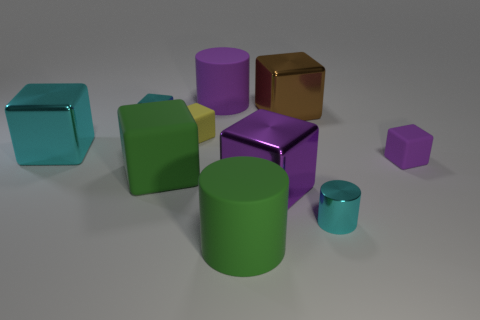Subtract all metal cylinders. How many cylinders are left? 2 Subtract all brown blocks. How many blocks are left? 6 Subtract all cylinders. How many objects are left? 7 Subtract all cyan cylinders. Subtract all green blocks. How many cylinders are left? 2 Subtract all gray spheres. How many cyan cylinders are left? 1 Subtract all small yellow rubber cylinders. Subtract all brown things. How many objects are left? 9 Add 2 small matte blocks. How many small matte blocks are left? 4 Add 5 big purple rubber objects. How many big purple rubber objects exist? 6 Subtract 1 purple cylinders. How many objects are left? 9 Subtract 3 blocks. How many blocks are left? 4 